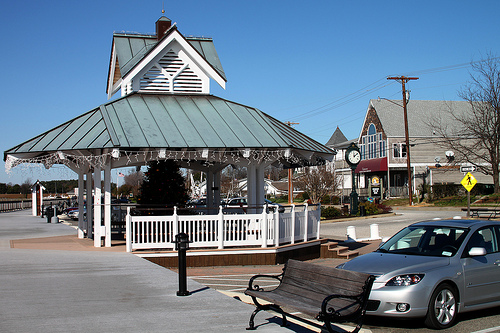Describe the architectural style of the gazebo in the image. The gazebo in the image features a classic pavilion-style architecture, characterized by its open sides and peaked roof. It has a decorative trim and supports columns, while the roof is covered with what appears to be a metallic or wooden material, enhancing its traditional yet elegant look. What material do you think the gazebo's roof is made of? The gazebo's roof seems to be made of a metallic material, likely galvanized steel or aluminum, given its reflective surface and the way it catches light. The choice of material contributes to its durability and weather resistance. 